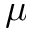Convert formula to latex. <formula><loc_0><loc_0><loc_500><loc_500>\mu</formula> 